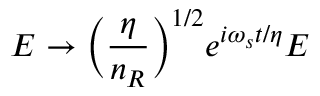Convert formula to latex. <formula><loc_0><loc_0><loc_500><loc_500>E \rightarrow \left ( \frac { \eta } { n _ { R } } \right ) ^ { 1 / 2 } e ^ { i \omega _ { s } t / \eta } E</formula> 